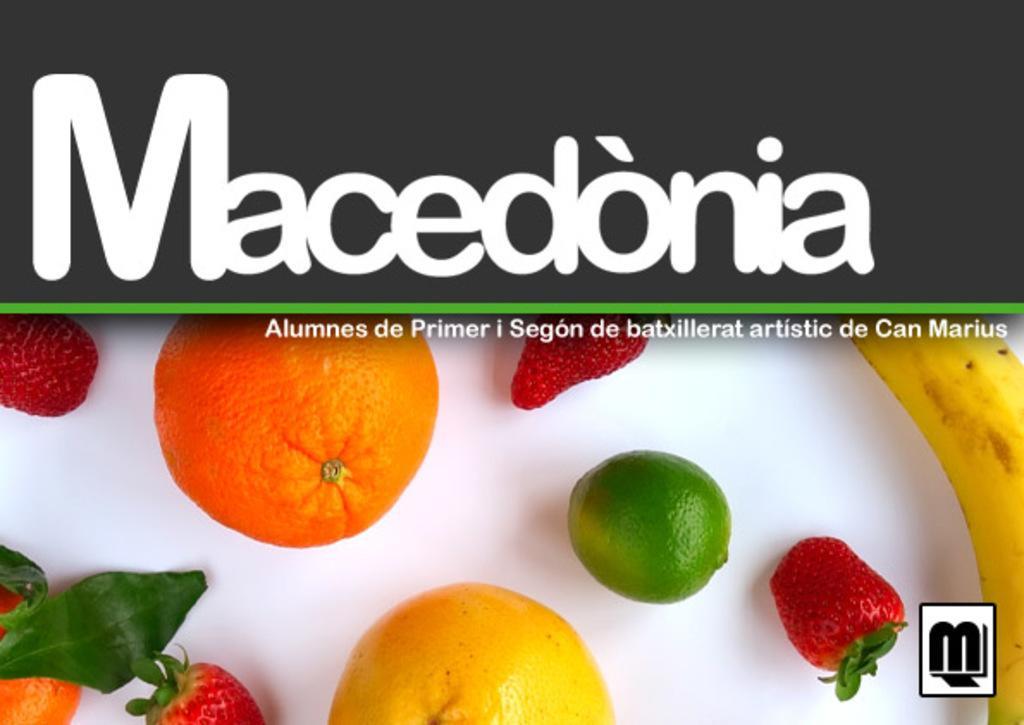Could you give a brief overview of what you see in this image? In this picture we can see a poster with many fruits on it. 